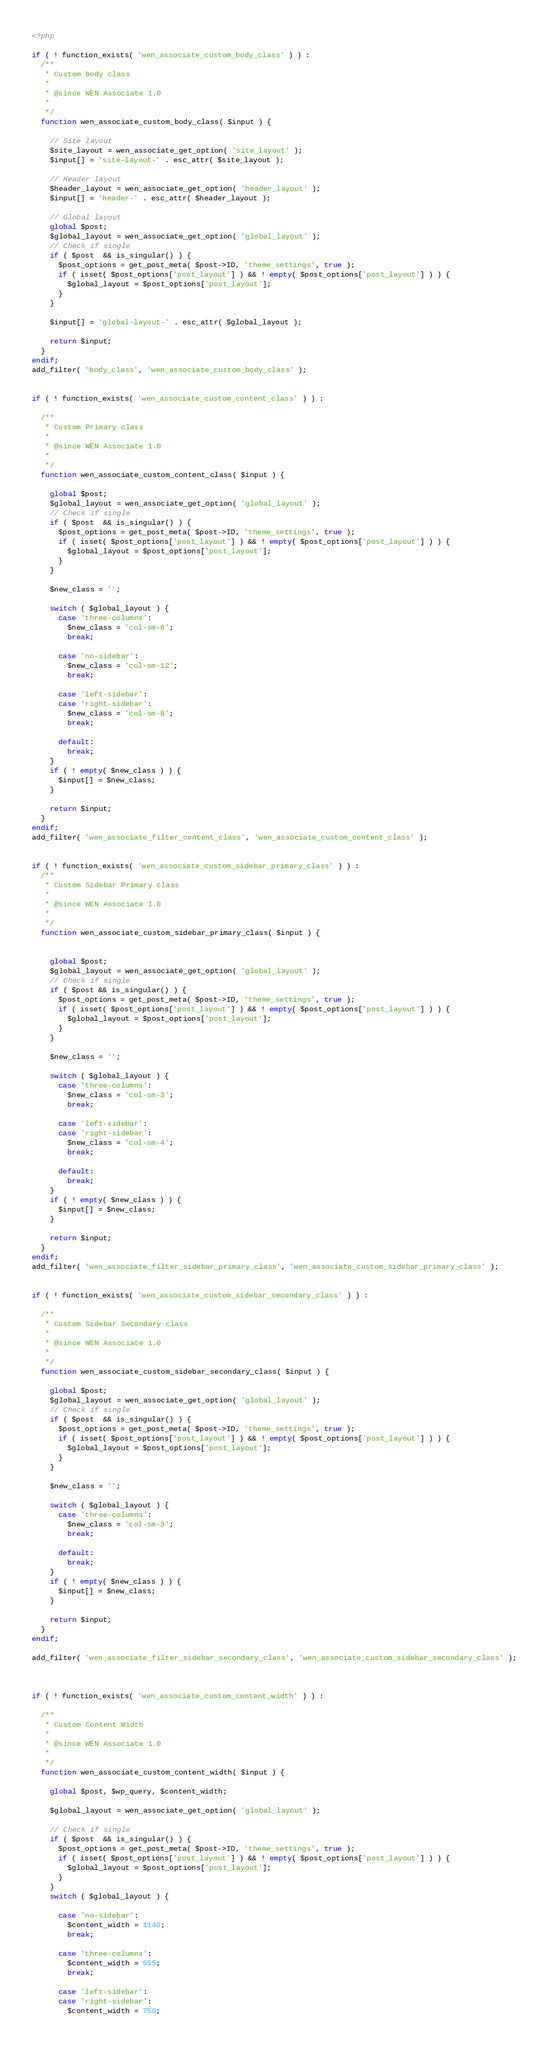<code> <loc_0><loc_0><loc_500><loc_500><_PHP_><?php

if ( ! function_exists( 'wen_associate_custom_body_class' ) ) :
  /**
   * Custom body class
   *
   * @since WEN Associate 1.0
   *
   */
  function wen_associate_custom_body_class( $input ) {

    // Site layout
    $site_layout = wen_associate_get_option( 'site_layout' );
    $input[] = 'site-layout-' . esc_attr( $site_layout );

    // Header layout
    $header_layout = wen_associate_get_option( 'header_layout' );
    $input[] = 'header-' . esc_attr( $header_layout );

    // Global layout
    global $post;
    $global_layout = wen_associate_get_option( 'global_layout' );
    // Check if single
    if ( $post  && is_singular() ) {
      $post_options = get_post_meta( $post->ID, 'theme_settings', true );
      if ( isset( $post_options['post_layout'] ) && ! empty( $post_options['post_layout'] ) ) {
        $global_layout = $post_options['post_layout'];
      }
    }

    $input[] = 'global-layout-' . esc_attr( $global_layout );

    return $input;
  }
endif;
add_filter( 'body_class', 'wen_associate_custom_body_class' );


if ( ! function_exists( 'wen_associate_custom_content_class' ) ) :

  /**
   * Custom Primary class
   *
   * @since WEN Associate 1.0
   *
   */
  function wen_associate_custom_content_class( $input ) {

    global $post;
    $global_layout = wen_associate_get_option( 'global_layout' );
    // Check if single
    if ( $post  && is_singular() ) {
      $post_options = get_post_meta( $post->ID, 'theme_settings', true );
      if ( isset( $post_options['post_layout'] ) && ! empty( $post_options['post_layout'] ) ) {
        $global_layout = $post_options['post_layout'];
      }
    }

    $new_class = '';

    switch ( $global_layout ) {
      case 'three-columns':
        $new_class = 'col-sm-6';
        break;

      case 'no-sidebar':
        $new_class = 'col-sm-12';
        break;

      case 'left-sidebar':
      case 'right-sidebar':
        $new_class = 'col-sm-8';
        break;

      default:
        break;
    }
    if ( ! empty( $new_class ) ) {
      $input[] = $new_class;
    }

    return $input;
  }
endif;
add_filter( 'wen_associate_filter_content_class', 'wen_associate_custom_content_class' );


if ( ! function_exists( 'wen_associate_custom_sidebar_primary_class' ) ) :
  /**
   * Custom Sidebar Primary class
   *
   * @since WEN Associate 1.0
   *
   */
  function wen_associate_custom_sidebar_primary_class( $input ) {


    global $post;
    $global_layout = wen_associate_get_option( 'global_layout' );
    // Check if single
    if ( $post && is_singular() ) {
      $post_options = get_post_meta( $post->ID, 'theme_settings', true );
      if ( isset( $post_options['post_layout'] ) && ! empty( $post_options['post_layout'] ) ) {
        $global_layout = $post_options['post_layout'];
      }
    }

    $new_class = '';

    switch ( $global_layout ) {
      case 'three-columns':
        $new_class = 'col-sm-3';
        break;

      case 'left-sidebar':
      case 'right-sidebar':
        $new_class = 'col-sm-4';
        break;

      default:
        break;
    }
    if ( ! empty( $new_class ) ) {
      $input[] = $new_class;
    }

    return $input;
  }
endif;
add_filter( 'wen_associate_filter_sidebar_primary_class', 'wen_associate_custom_sidebar_primary_class' );


if ( ! function_exists( 'wen_associate_custom_sidebar_secondary_class' ) ) :

  /**
   * Custom Sidebar Secondary class
   *
   * @since WEN Associate 1.0
   *
   */
  function wen_associate_custom_sidebar_secondary_class( $input ) {

    global $post;
    $global_layout = wen_associate_get_option( 'global_layout' );
    // Check if single
    if ( $post  && is_singular() ) {
      $post_options = get_post_meta( $post->ID, 'theme_settings', true );
      if ( isset( $post_options['post_layout'] ) && ! empty( $post_options['post_layout'] ) ) {
        $global_layout = $post_options['post_layout'];
      }
    }

    $new_class = '';

    switch ( $global_layout ) {
      case 'three-columns':
        $new_class = 'col-sm-3';
        break;

      default:
        break;
    }
    if ( ! empty( $new_class ) ) {
      $input[] = $new_class;
    }

    return $input;
  }
endif;

add_filter( 'wen_associate_filter_sidebar_secondary_class', 'wen_associate_custom_sidebar_secondary_class' );



if ( ! function_exists( 'wen_associate_custom_content_width' ) ) :

  /**
   * Custom Content Width
   *
   * @since WEN Associate 1.0
   *
   */
  function wen_associate_custom_content_width( $input ) {

    global $post, $wp_query, $content_width;

    $global_layout = wen_associate_get_option( 'global_layout' );

    // Check if single
    if ( $post  && is_singular() ) {
      $post_options = get_post_meta( $post->ID, 'theme_settings', true );
      if ( isset( $post_options['post_layout'] ) && ! empty( $post_options['post_layout'] ) ) {
        $global_layout = $post_options['post_layout'];
      }
    }
    switch ( $global_layout ) {

      case 'no-sidebar':
        $content_width = 1140;
        break;

      case 'three-columns':
        $content_width = 555;
        break;

      case 'left-sidebar':
      case 'right-sidebar':
        $content_width = 750;</code> 